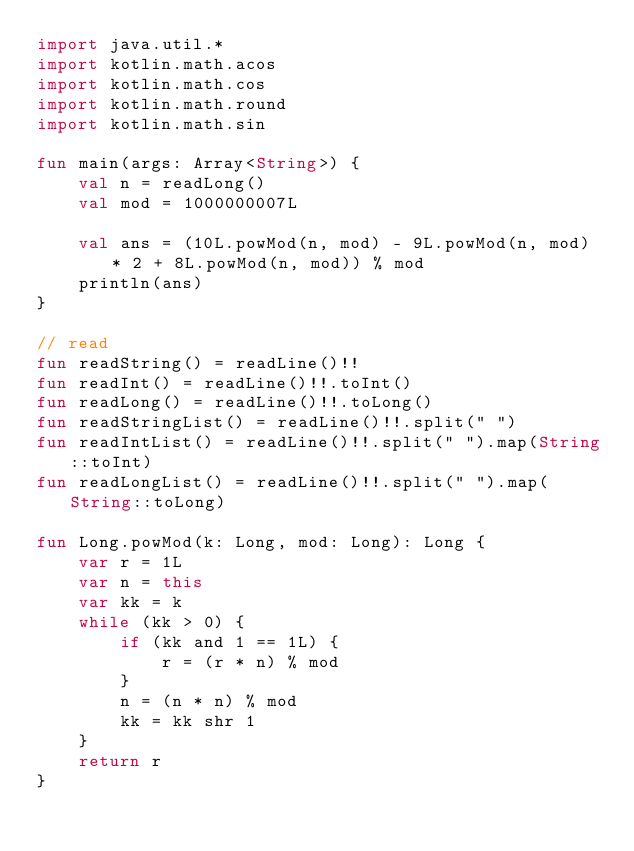Convert code to text. <code><loc_0><loc_0><loc_500><loc_500><_Kotlin_>import java.util.*
import kotlin.math.acos
import kotlin.math.cos
import kotlin.math.round
import kotlin.math.sin

fun main(args: Array<String>) {
    val n = readLong()
    val mod = 1000000007L

    val ans = (10L.powMod(n, mod) - 9L.powMod(n, mod) * 2 + 8L.powMod(n, mod)) % mod
    println(ans)
}

// read
fun readString() = readLine()!!
fun readInt() = readLine()!!.toInt()
fun readLong() = readLine()!!.toLong()
fun readStringList() = readLine()!!.split(" ")
fun readIntList() = readLine()!!.split(" ").map(String::toInt)
fun readLongList() = readLine()!!.split(" ").map(String::toLong)

fun Long.powMod(k: Long, mod: Long): Long {
    var r = 1L
    var n = this
    var kk = k
    while (kk > 0) {
        if (kk and 1 == 1L) {
            r = (r * n) % mod
        }
        n = (n * n) % mod
        kk = kk shr 1
    }
    return r
}
</code> 